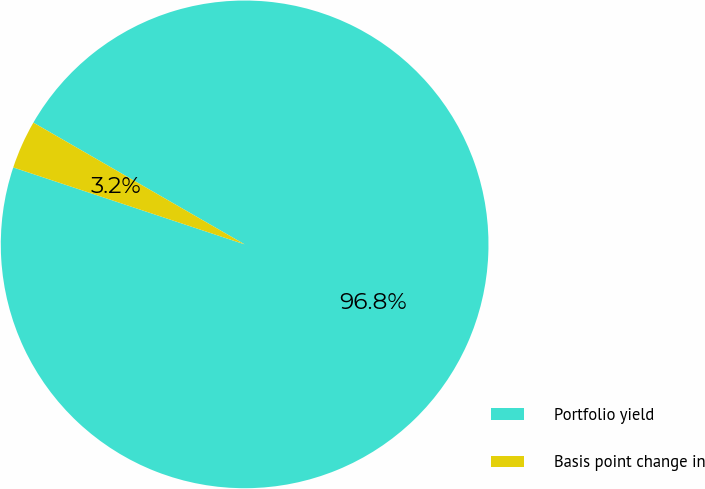Convert chart. <chart><loc_0><loc_0><loc_500><loc_500><pie_chart><fcel>Portfolio yield<fcel>Basis point change in<nl><fcel>96.79%<fcel>3.21%<nl></chart> 